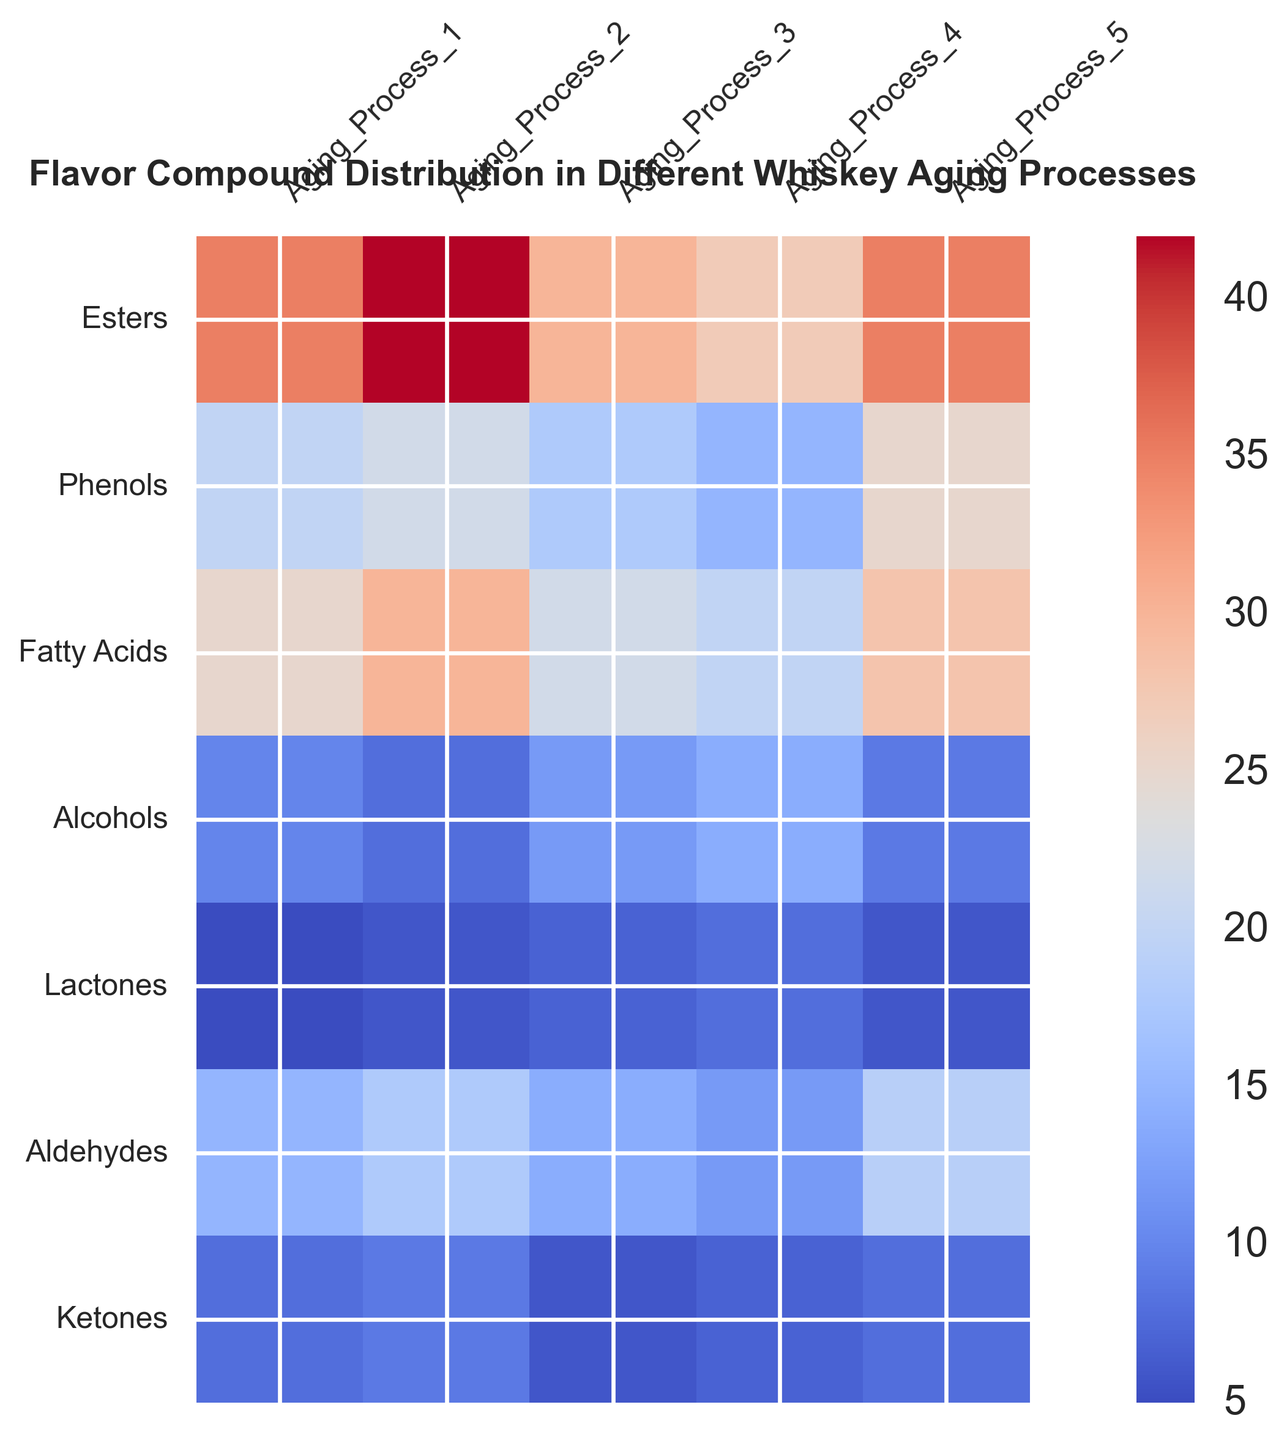Which aging process has the highest concentration of esters? Look at the row for "Esters" and identify the highest value across the aging processes. Aging Process 2 has the highest concentration with a value of 42.
Answer: Aging Process 2 Which compound has the lowest concentration in Aging Process 4? Examine the column for "Aging Process 4" and find the smallest value. Lactones have the lowest concentration with a value of 8.
Answer: Lactones What's the average concentration of phenols across all aging processes? Sum the concentrations of phenols in all aging processes (20 + 22 + 18 + 15 + 25) = 100, then divide by the number of aging processes (5). So, the average is 100/5 = 20.
Answer: 20 Compare the concentrations of fatty acids and alcohols in Aging Process 3. Which one is higher? Look at the values for "Fatty Acids" and "Alcohols" in Aging Process 3. Fatty Acids are 22, and Alcohols are 12. Therefore, Fatty Acids have a higher concentration.
Answer: Fatty Acids What is the total concentration of aldehydes in Aging Processes 1 and 5 combined? Add the concentrations of aldehydes in Aging Process 1 and Aging Process 5: 15 + 19 = 34.
Answer: 34 Which compound shows the most consistent concentration across all aging processes, as indicated by the least range? Calculate the range (max - min) for each compound across all aging processes. Find the compound with the smallest range. Esters: 42-27=15, Phenols: 25-15=10, Fatty Acids: 30-20=10, Alcohols: 14-8=6, Lactones: 8-5=3, Aldehydes: 19-12=7, Ketones: 9-6=3. Ketones have the smallest range (3).
Answer: Ketones In which aging process does the concentration of alcohols peak and what is the value? Look at the row for "Alcohols" and identify the highest value and its corresponding aging process. The concentration peaks in Aging Process 4 with a value of 14.
Answer: Aging Process 4 What is the difference in concentration of fatty acids between Aging Process 2 and Aging Process 5? Subtract the concentration of fatty acids in Aging Process 5 from that in Aging Process 2: 30 - 28 = 2.
Answer: 2 Calculate the average concentration of all compounds in Aging Process 1. Add the concentrations of all compounds in Aging Process 1 (35 + 20 + 25 + 10 + 5 + 15 + 8) = 118, then divide by the number of compounds (7). The average is 118/7 ≈ 16.86.
Answer: 16.86 